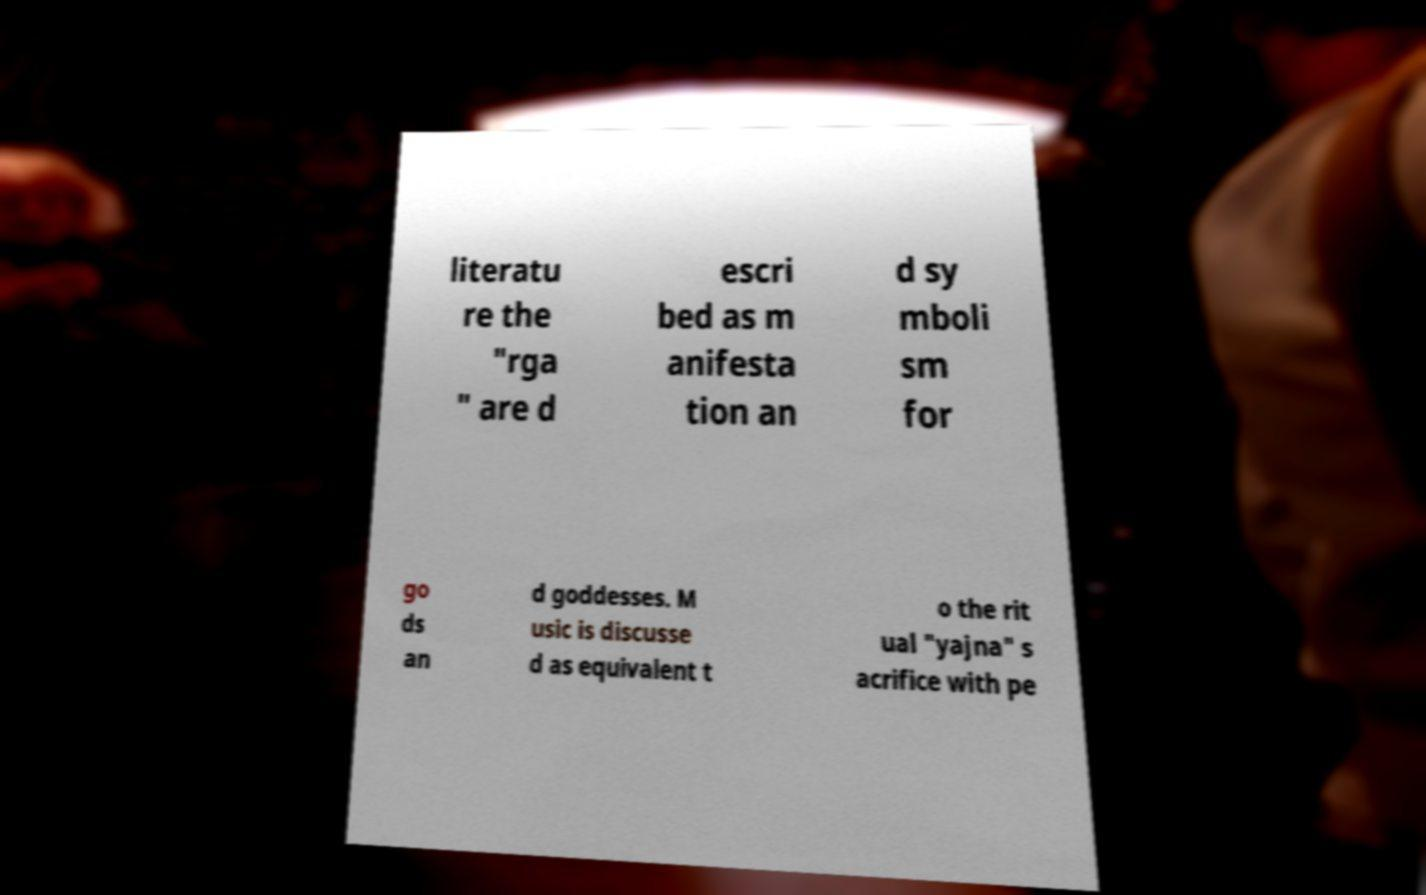Can you read and provide the text displayed in the image?This photo seems to have some interesting text. Can you extract and type it out for me? literatu re the "rga " are d escri bed as m anifesta tion an d sy mboli sm for go ds an d goddesses. M usic is discusse d as equivalent t o the rit ual "yajna" s acrifice with pe 